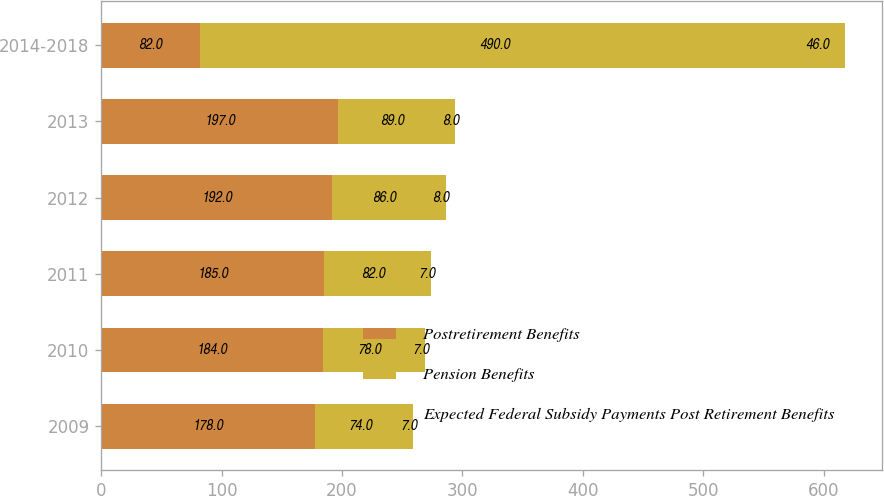Convert chart to OTSL. <chart><loc_0><loc_0><loc_500><loc_500><stacked_bar_chart><ecel><fcel>2009<fcel>2010<fcel>2011<fcel>2012<fcel>2013<fcel>2014-2018<nl><fcel>Postretirement Benefits<fcel>178<fcel>184<fcel>185<fcel>192<fcel>197<fcel>82<nl><fcel>Pension Benefits<fcel>74<fcel>78<fcel>82<fcel>86<fcel>89<fcel>490<nl><fcel>Expected Federal Subsidy Payments Post Retirement Benefits<fcel>7<fcel>7<fcel>7<fcel>8<fcel>8<fcel>46<nl></chart> 